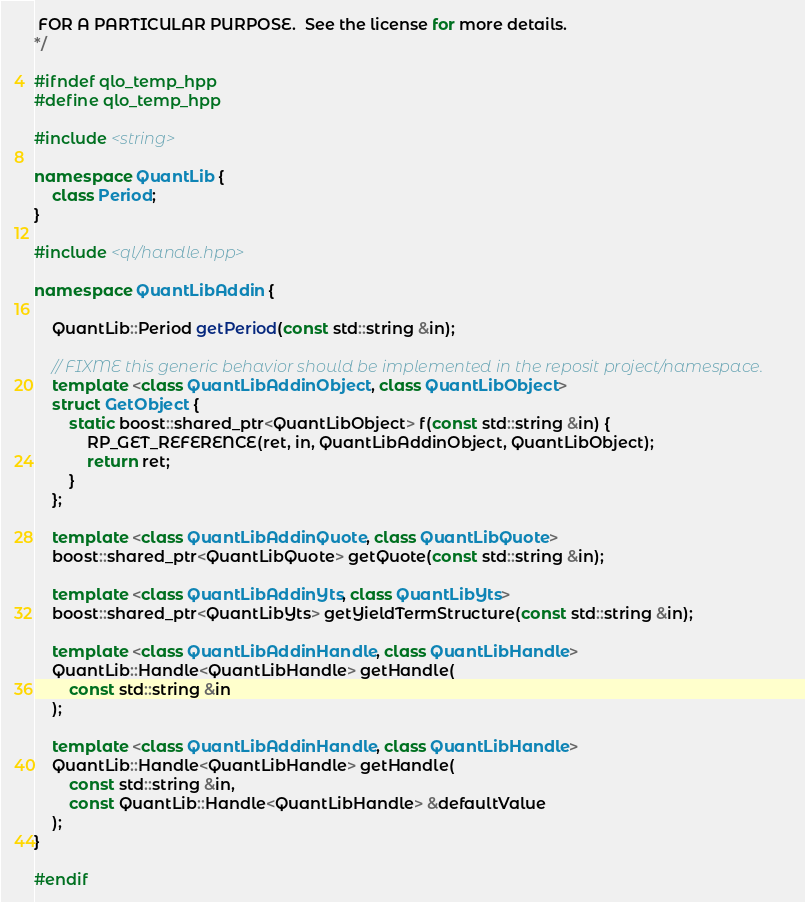<code> <loc_0><loc_0><loc_500><loc_500><_C++_> FOR A PARTICULAR PURPOSE.  See the license for more details.
*/

#ifndef qlo_temp_hpp
#define qlo_temp_hpp

#include <string>

namespace QuantLib {
    class Period;
}

#include <ql/handle.hpp>

namespace QuantLibAddin {

    QuantLib::Period getPeriod(const std::string &in);

    // FIXME this generic behavior should be implemented in the reposit project/namespace.
    template <class QuantLibAddinObject, class QuantLibObject>
    struct GetObject {
        static boost::shared_ptr<QuantLibObject> f(const std::string &in) {
            RP_GET_REFERENCE(ret, in, QuantLibAddinObject, QuantLibObject);
            return ret;
        }
    };

    template <class QuantLibAddinQuote, class QuantLibQuote>
    boost::shared_ptr<QuantLibQuote> getQuote(const std::string &in);

    template <class QuantLibAddinYts, class QuantLibYts>
    boost::shared_ptr<QuantLibYts> getYieldTermStructure(const std::string &in);

    template <class QuantLibAddinHandle, class QuantLibHandle>
    QuantLib::Handle<QuantLibHandle> getHandle(
        const std::string &in
    );

    template <class QuantLibAddinHandle, class QuantLibHandle>
    QuantLib::Handle<QuantLibHandle> getHandle(
        const std::string &in,
        const QuantLib::Handle<QuantLibHandle> &defaultValue
    );
}

#endif

</code> 